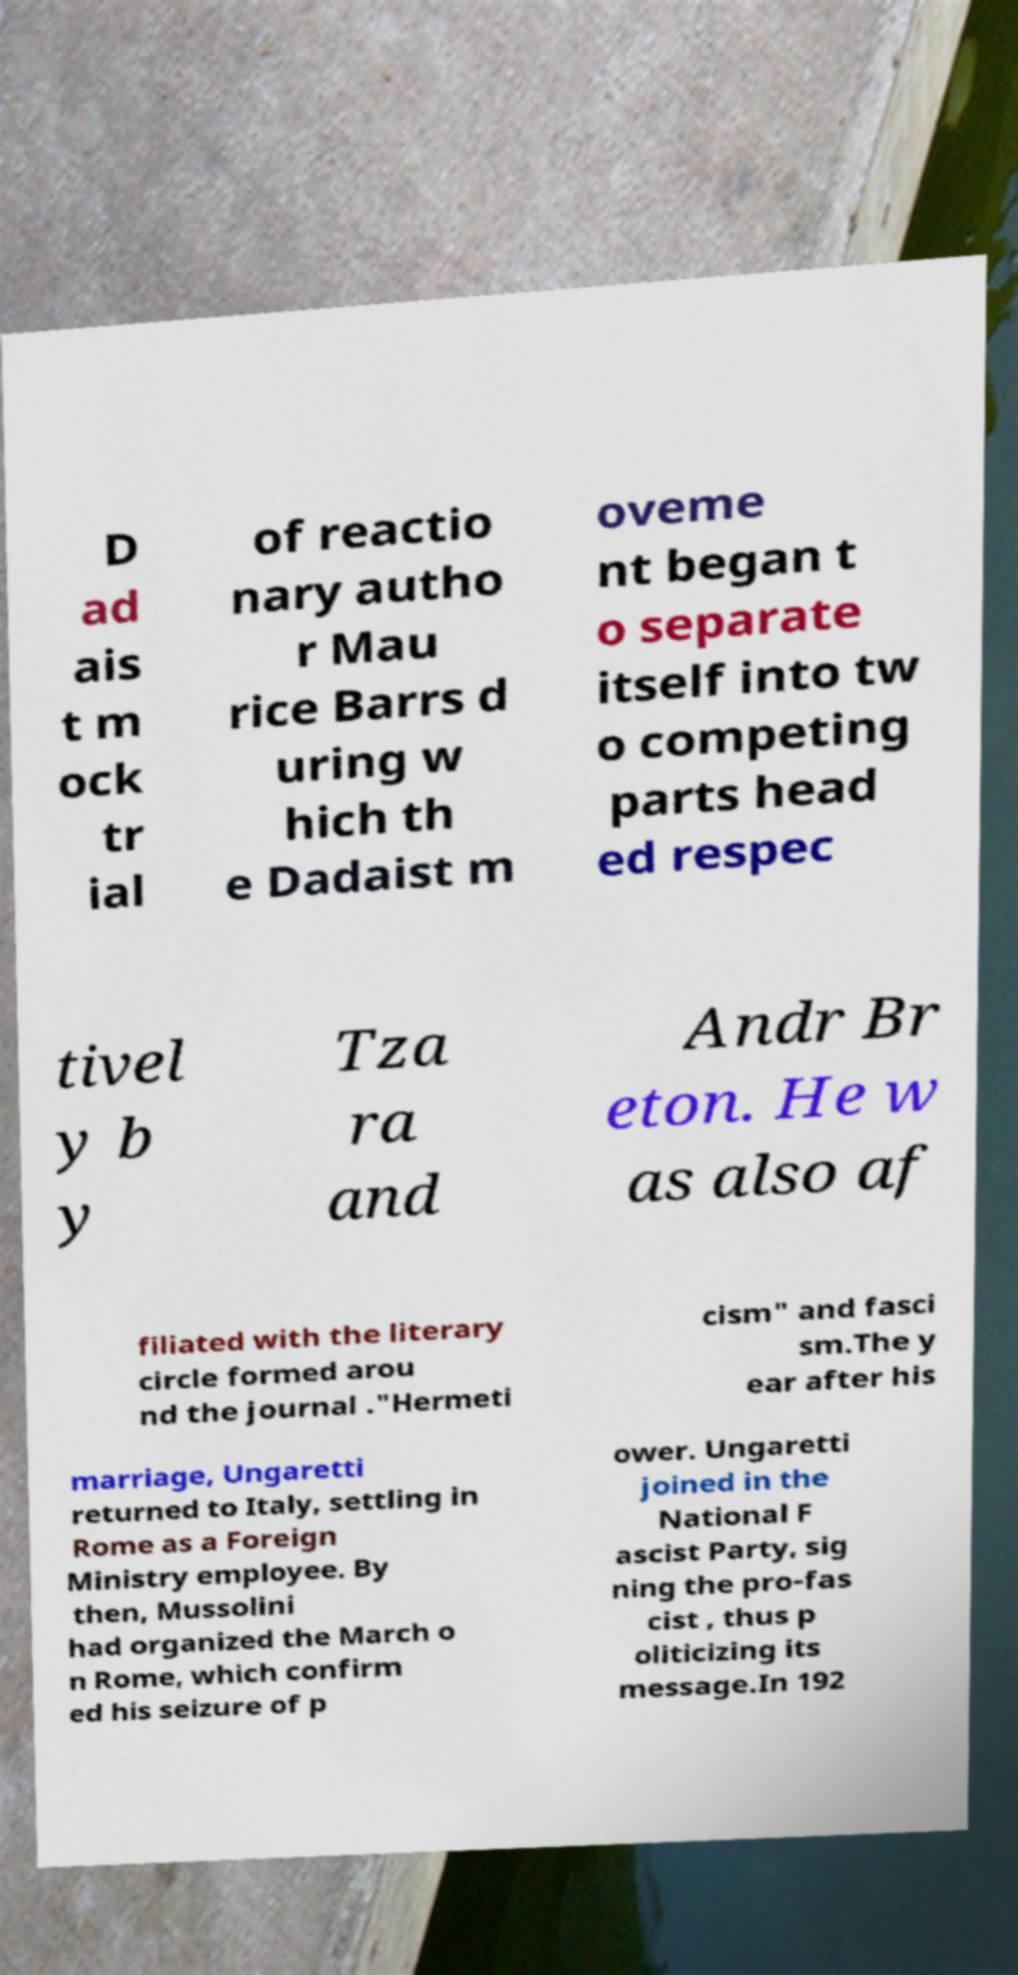There's text embedded in this image that I need extracted. Can you transcribe it verbatim? D ad ais t m ock tr ial of reactio nary autho r Mau rice Barrs d uring w hich th e Dadaist m oveme nt began t o separate itself into tw o competing parts head ed respec tivel y b y Tza ra and Andr Br eton. He w as also af filiated with the literary circle formed arou nd the journal ."Hermeti cism" and fasci sm.The y ear after his marriage, Ungaretti returned to Italy, settling in Rome as a Foreign Ministry employee. By then, Mussolini had organized the March o n Rome, which confirm ed his seizure of p ower. Ungaretti joined in the National F ascist Party, sig ning the pro-fas cist , thus p oliticizing its message.In 192 